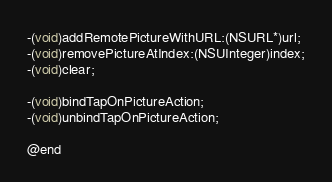Convert code to text. <code><loc_0><loc_0><loc_500><loc_500><_C_>-(void)addRemotePictureWithURL:(NSURL*)url;
-(void)removePictureAtIndex:(NSUInteger)index;
-(void)clear;

-(void)bindTapOnPictureAction;
-(void)unbindTapOnPictureAction;

@end
</code> 